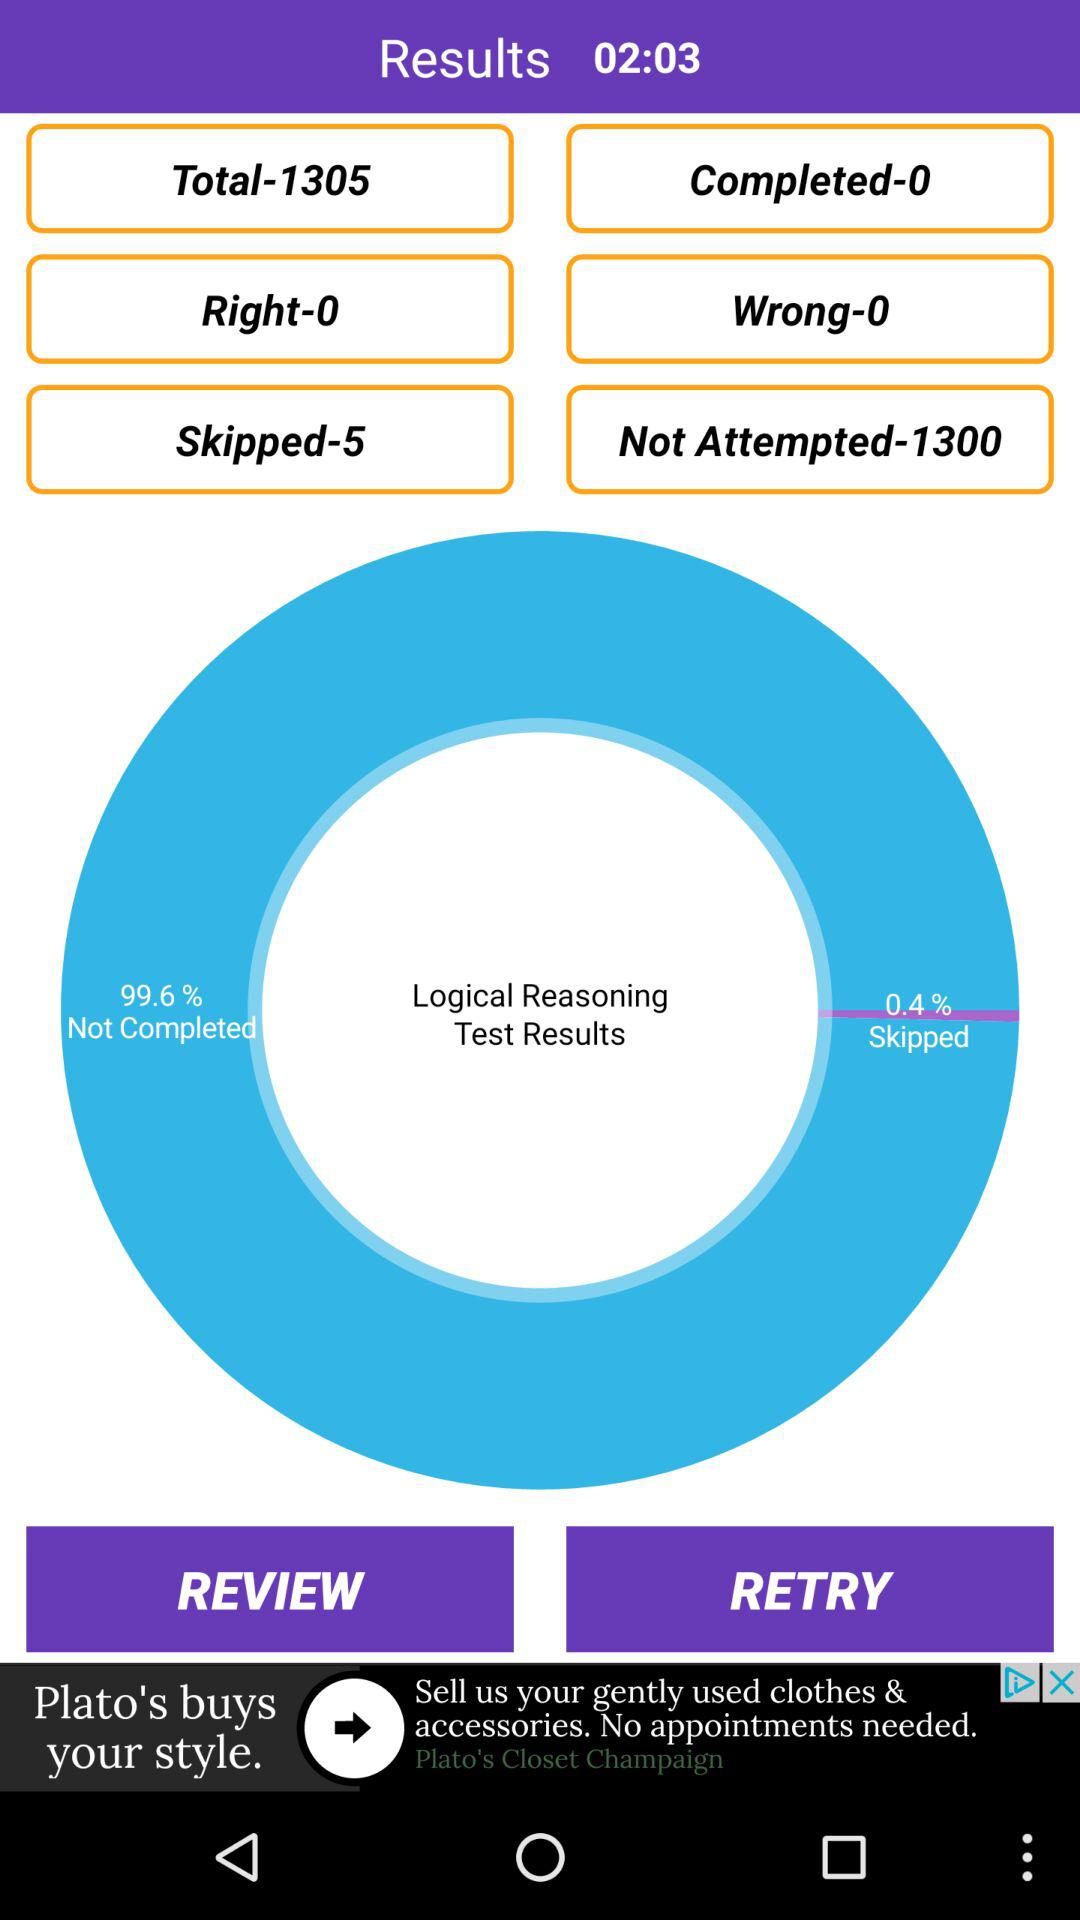How many questions are wrong? There are 0 wrong questions. 